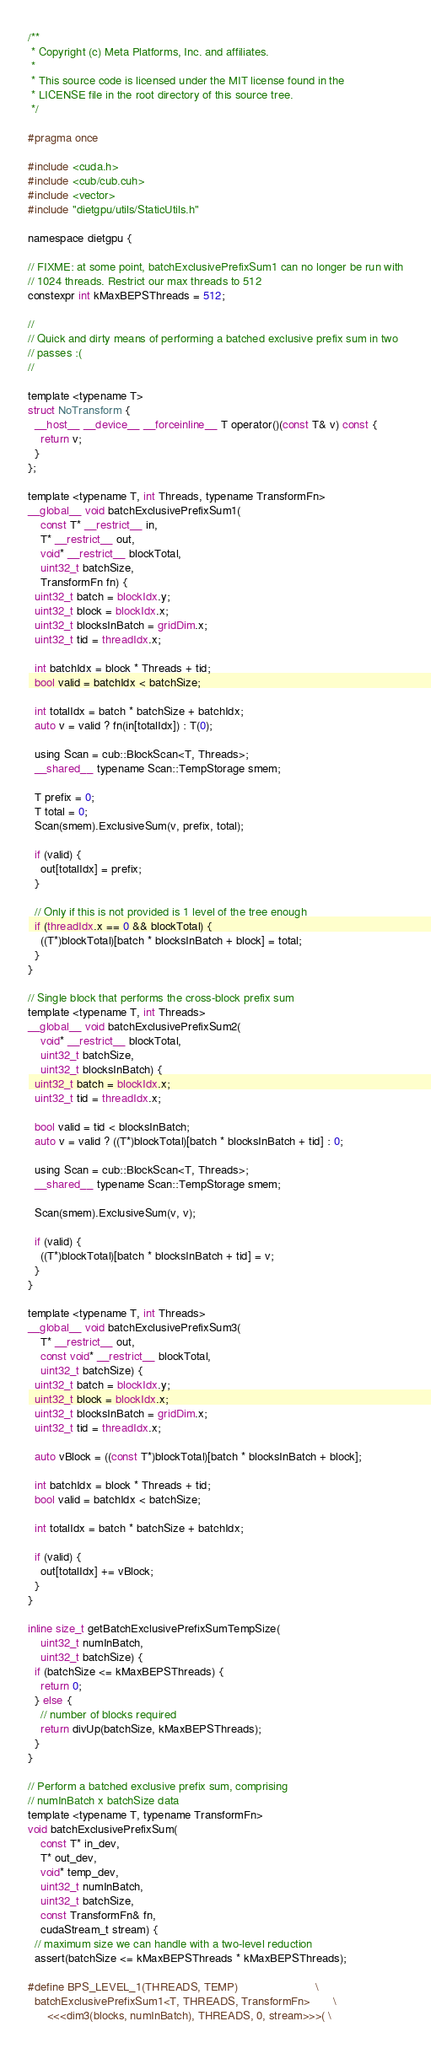<code> <loc_0><loc_0><loc_500><loc_500><_Cuda_>/**
 * Copyright (c) Meta Platforms, Inc. and affiliates.
 *
 * This source code is licensed under the MIT license found in the
 * LICENSE file in the root directory of this source tree.
 */

#pragma once

#include <cuda.h>
#include <cub/cub.cuh>
#include <vector>
#include "dietgpu/utils/StaticUtils.h"

namespace dietgpu {

// FIXME: at some point, batchExclusivePrefixSum1 can no longer be run with
// 1024 threads. Restrict our max threads to 512
constexpr int kMaxBEPSThreads = 512;

//
// Quick and dirty means of performing a batched exclusive prefix sum in two
// passes :(
//

template <typename T>
struct NoTransform {
  __host__ __device__ __forceinline__ T operator()(const T& v) const {
    return v;
  }
};

template <typename T, int Threads, typename TransformFn>
__global__ void batchExclusivePrefixSum1(
    const T* __restrict__ in,
    T* __restrict__ out,
    void* __restrict__ blockTotal,
    uint32_t batchSize,
    TransformFn fn) {
  uint32_t batch = blockIdx.y;
  uint32_t block = blockIdx.x;
  uint32_t blocksInBatch = gridDim.x;
  uint32_t tid = threadIdx.x;

  int batchIdx = block * Threads + tid;
  bool valid = batchIdx < batchSize;

  int totalIdx = batch * batchSize + batchIdx;
  auto v = valid ? fn(in[totalIdx]) : T(0);

  using Scan = cub::BlockScan<T, Threads>;
  __shared__ typename Scan::TempStorage smem;

  T prefix = 0;
  T total = 0;
  Scan(smem).ExclusiveSum(v, prefix, total);

  if (valid) {
    out[totalIdx] = prefix;
  }

  // Only if this is not provided is 1 level of the tree enough
  if (threadIdx.x == 0 && blockTotal) {
    ((T*)blockTotal)[batch * blocksInBatch + block] = total;
  }
}

// Single block that performs the cross-block prefix sum
template <typename T, int Threads>
__global__ void batchExclusivePrefixSum2(
    void* __restrict__ blockTotal,
    uint32_t batchSize,
    uint32_t blocksInBatch) {
  uint32_t batch = blockIdx.x;
  uint32_t tid = threadIdx.x;

  bool valid = tid < blocksInBatch;
  auto v = valid ? ((T*)blockTotal)[batch * blocksInBatch + tid] : 0;

  using Scan = cub::BlockScan<T, Threads>;
  __shared__ typename Scan::TempStorage smem;

  Scan(smem).ExclusiveSum(v, v);

  if (valid) {
    ((T*)blockTotal)[batch * blocksInBatch + tid] = v;
  }
}

template <typename T, int Threads>
__global__ void batchExclusivePrefixSum3(
    T* __restrict__ out,
    const void* __restrict__ blockTotal,
    uint32_t batchSize) {
  uint32_t batch = blockIdx.y;
  uint32_t block = blockIdx.x;
  uint32_t blocksInBatch = gridDim.x;
  uint32_t tid = threadIdx.x;

  auto vBlock = ((const T*)blockTotal)[batch * blocksInBatch + block];

  int batchIdx = block * Threads + tid;
  bool valid = batchIdx < batchSize;

  int totalIdx = batch * batchSize + batchIdx;

  if (valid) {
    out[totalIdx] += vBlock;
  }
}

inline size_t getBatchExclusivePrefixSumTempSize(
    uint32_t numInBatch,
    uint32_t batchSize) {
  if (batchSize <= kMaxBEPSThreads) {
    return 0;
  } else {
    // number of blocks required
    return divUp(batchSize, kMaxBEPSThreads);
  }
}

// Perform a batched exclusive prefix sum, comprising
// numInBatch x batchSize data
template <typename T, typename TransformFn>
void batchExclusivePrefixSum(
    const T* in_dev,
    T* out_dev,
    void* temp_dev,
    uint32_t numInBatch,
    uint32_t batchSize,
    const TransformFn& fn,
    cudaStream_t stream) {
  // maximum size we can handle with a two-level reduction
  assert(batchSize <= kMaxBEPSThreads * kMaxBEPSThreads);

#define BPS_LEVEL_1(THREADS, TEMP)                        \
  batchExclusivePrefixSum1<T, THREADS, TransformFn>       \
      <<<dim3(blocks, numInBatch), THREADS, 0, stream>>>( \</code> 